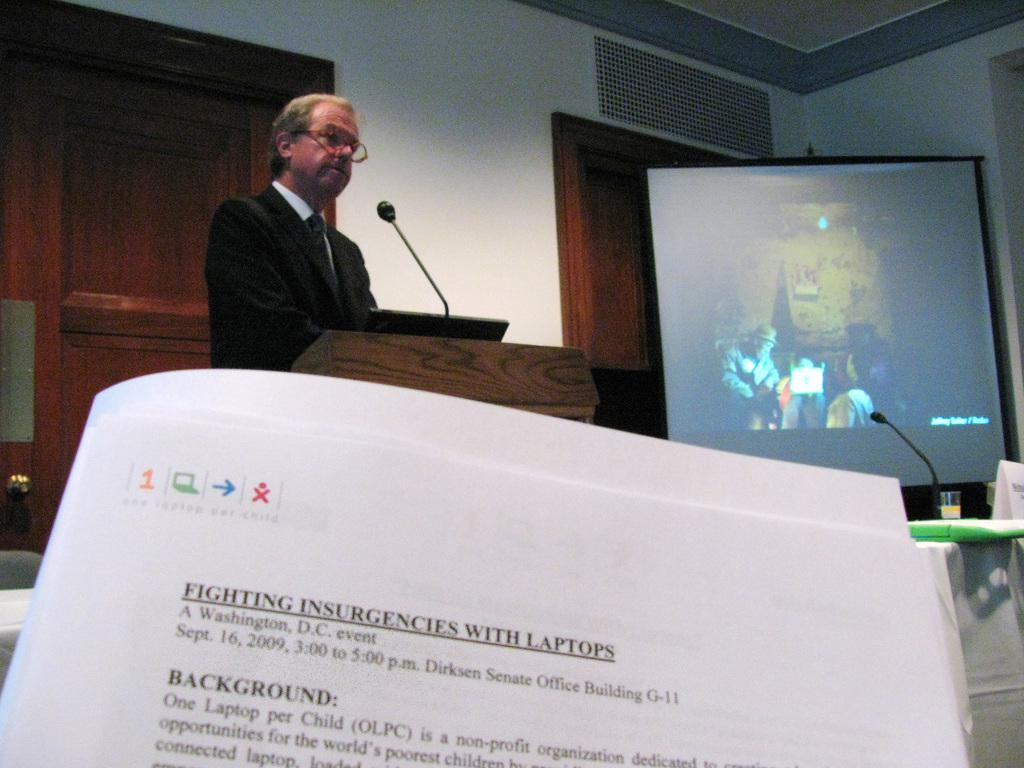<image>
Give a short and clear explanation of the subsequent image. a sheet of paper with the word fighting on it 